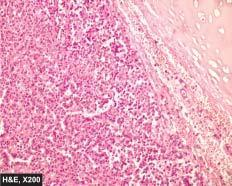does the tumour show a characteristic nested of cells separated by fibrovascular septa?
Answer the question using a single word or phrase. Yes 